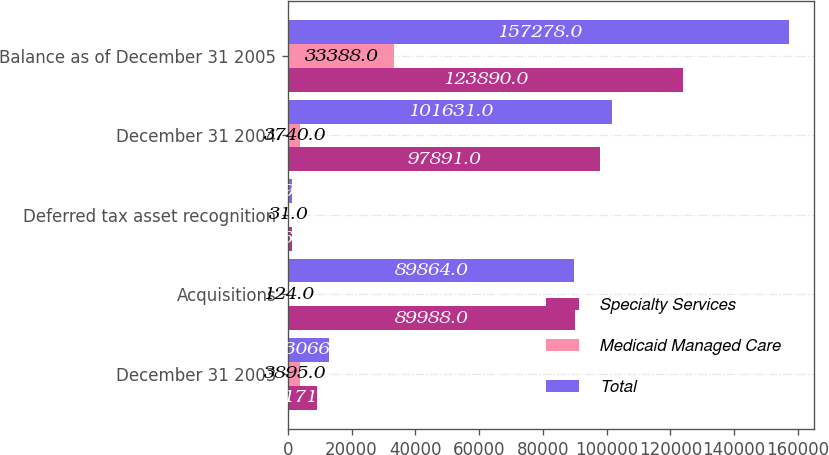Convert chart. <chart><loc_0><loc_0><loc_500><loc_500><stacked_bar_chart><ecel><fcel>December 31 2003<fcel>Acquisitions<fcel>Deferred tax asset recognition<fcel>December 31 2004<fcel>Balance as of December 31 2005<nl><fcel>Specialty Services<fcel>9171<fcel>89988<fcel>1268<fcel>97891<fcel>123890<nl><fcel>Medicaid Managed Care<fcel>3895<fcel>124<fcel>31<fcel>3740<fcel>33388<nl><fcel>Total<fcel>13066<fcel>89864<fcel>1299<fcel>101631<fcel>157278<nl></chart> 